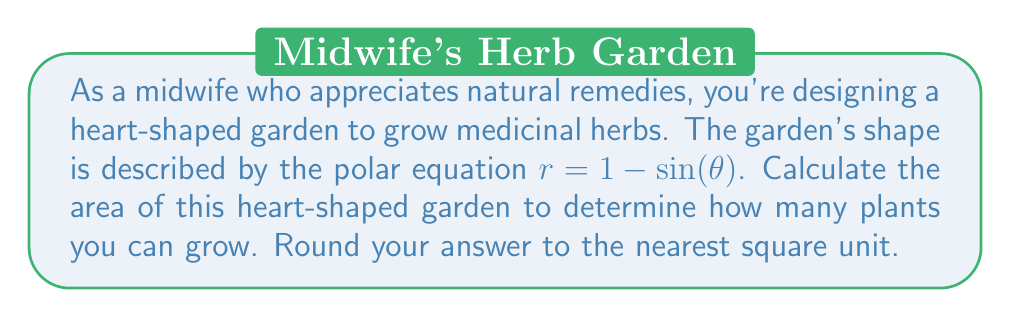Provide a solution to this math problem. To calculate the area of the heart-shaped curve in polar coordinates, we'll follow these steps:

1) The general formula for the area of a region bounded by a polar curve is:

   $$A = \frac{1}{2} \int_{0}^{2\pi} r^2 d\theta$$

2) Our curve is given by $r = 1 - \sin(\theta)$. We need to square this:

   $$r^2 = (1 - \sin(\theta))^2 = 1 - 2\sin(\theta) + \sin^2(\theta)$$

3) Now we can set up our integral:

   $$A = \frac{1}{2} \int_{0}^{2\pi} (1 - 2\sin(\theta) + \sin^2(\theta)) d\theta$$

4) Let's integrate each term separately:

   $$\begin{align*}
   A &= \frac{1}{2} \left[ \theta - 2(-\cos(\theta)) + \frac{\theta}{2} - \frac{\sin(2\theta)}{4} \right]_{0}^{2\pi} \\
   &= \frac{1}{2} \left[ (2\pi - 0) - 2(-\cos(2\pi) + \cos(0)) + (\pi - 0) - (\frac{\sin(4\pi)}{4} - \frac{\sin(0)}{4}) \right] \\
   &= \frac{1}{2} [2\pi - 2(0) + \pi - 0] \\
   &= \frac{1}{2} [3\pi] \\
   &= \frac{3\pi}{2}
   \end{align*}$$

5) The exact area is $\frac{3\pi}{2} \approx 4.71$ square units.

6) Rounding to the nearest square unit, we get 5 square units.

[asy]
import graph;
size(200);
real r(real t) {return 1-sin(t);}
path heart = polargraph(r, 0, 2pi, 300);
draw(heart, red+1);
xaxis("x", Arrow);
yaxis("y", Arrow);
label("Heart-shaped garden", (0.5,0.5), S);
[/asy]
Answer: 5 square units 